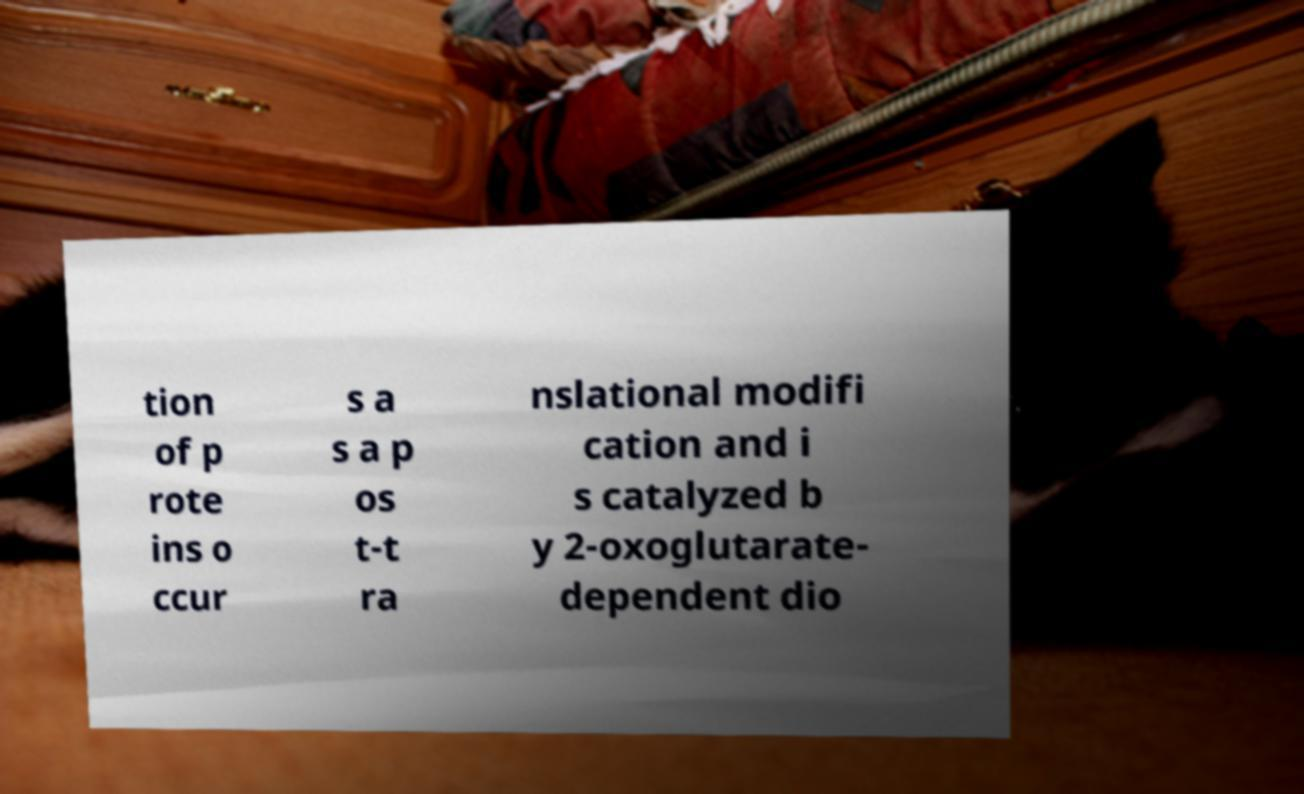Can you read and provide the text displayed in the image?This photo seems to have some interesting text. Can you extract and type it out for me? tion of p rote ins o ccur s a s a p os t-t ra nslational modifi cation and i s catalyzed b y 2-oxoglutarate- dependent dio 